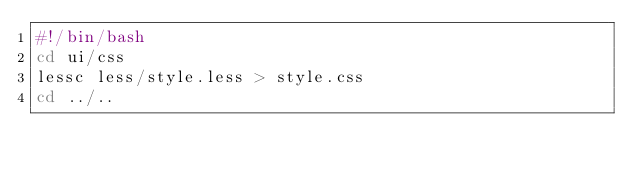<code> <loc_0><loc_0><loc_500><loc_500><_Bash_>#!/bin/bash
cd ui/css
lessc less/style.less > style.css
cd ../..
</code> 